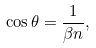<formula> <loc_0><loc_0><loc_500><loc_500>\cos \theta = \frac { 1 } { \beta n } ,</formula> 